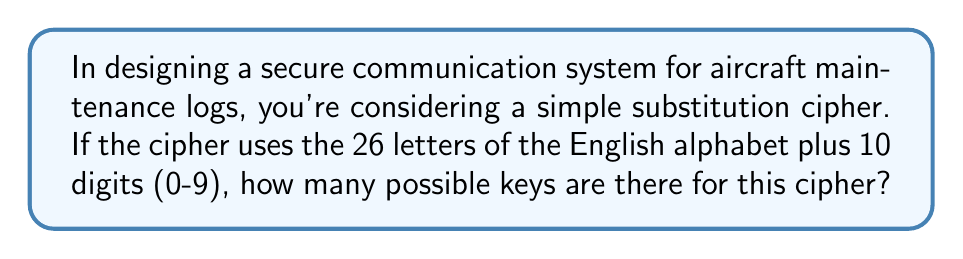Show me your answer to this math problem. Let's approach this step-by-step:

1) In a simple substitution cipher, each character in the plaintext is replaced by another character in the ciphertext.

2) We have 36 characters in total (26 letters + 10 digits).

3) For the first character, we have 36 choices.

4) For the second character, we have 35 choices (because one character has already been used).

5) For the third character, we have 34 choices, and so on.

6) This continues until we've assigned all 36 characters.

7) This scenario is a permutation of 36 elements, which is denoted as 36!.

8) Therefore, the number of possible keys is:

   $$36! = 36 \times 35 \times 34 \times ... \times 3 \times 2 \times 1$$

9) This can be calculated as:

   $$36! = 3.72 \times 10^{41}$$

This extremely large number demonstrates why simple substitution ciphers, while easy to implement, can be secure against brute-force attacks if the key space is large enough.
Answer: $36!$ or $3.72 \times 10^{41}$ 